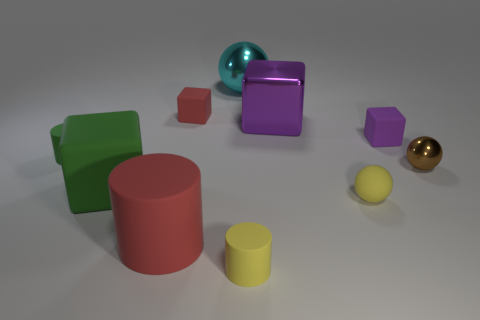What shape is the tiny matte thing that is to the left of the large red cylinder?
Keep it short and to the point. Cylinder. Are there fewer things that are in front of the red matte cube than big red things that are behind the brown shiny sphere?
Provide a succinct answer. No. There is a purple matte cube; does it have the same size as the matte block that is behind the small purple object?
Your answer should be compact. Yes. How many yellow rubber cylinders have the same size as the yellow rubber ball?
Provide a succinct answer. 1. The big cylinder that is made of the same material as the big green thing is what color?
Provide a succinct answer. Red. Is the number of matte cylinders greater than the number of yellow rubber cylinders?
Ensure brevity in your answer.  Yes. Is the material of the large purple object the same as the tiny purple block?
Provide a short and direct response. No. The tiny green object that is the same material as the small red object is what shape?
Offer a terse response. Cylinder. Is the number of small blue matte balls less than the number of tiny things?
Offer a terse response. Yes. The sphere that is both right of the large metal block and to the left of the small brown shiny thing is made of what material?
Provide a succinct answer. Rubber. 